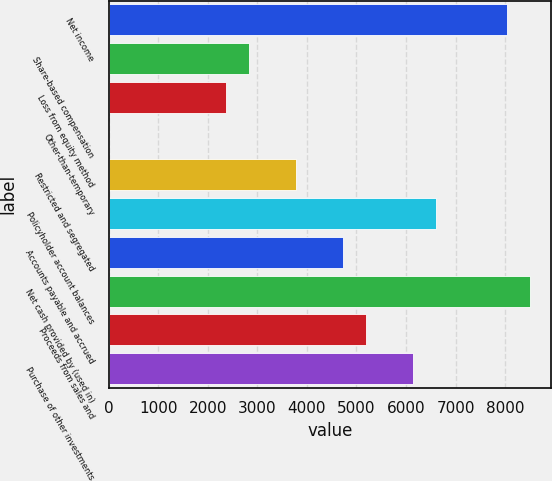Convert chart. <chart><loc_0><loc_0><loc_500><loc_500><bar_chart><fcel>Net income<fcel>Share-based compensation<fcel>Loss from equity method<fcel>Other-than-temporary<fcel>Restricted and segregated<fcel>Policyholder account balances<fcel>Accounts payable and accrued<fcel>Net cash provided by (used in)<fcel>Proceeds from sales and<fcel>Purchase of other investments<nl><fcel>8029<fcel>2837<fcel>2365<fcel>5<fcel>3781<fcel>6613<fcel>4725<fcel>8501<fcel>5197<fcel>6141<nl></chart> 